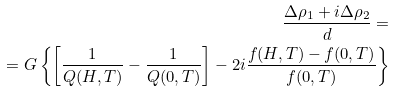Convert formula to latex. <formula><loc_0><loc_0><loc_500><loc_500>\frac { \Delta \rho _ { 1 } + i \Delta \rho _ { 2 } } { d } = \\ = G \left \{ \left [ \frac { 1 } { Q ( H , T ) } - \frac { 1 } { Q ( 0 , T ) } \right ] - 2 i \frac { f ( H , T ) - f ( 0 , T ) } { f ( 0 , T ) } \right \}</formula> 